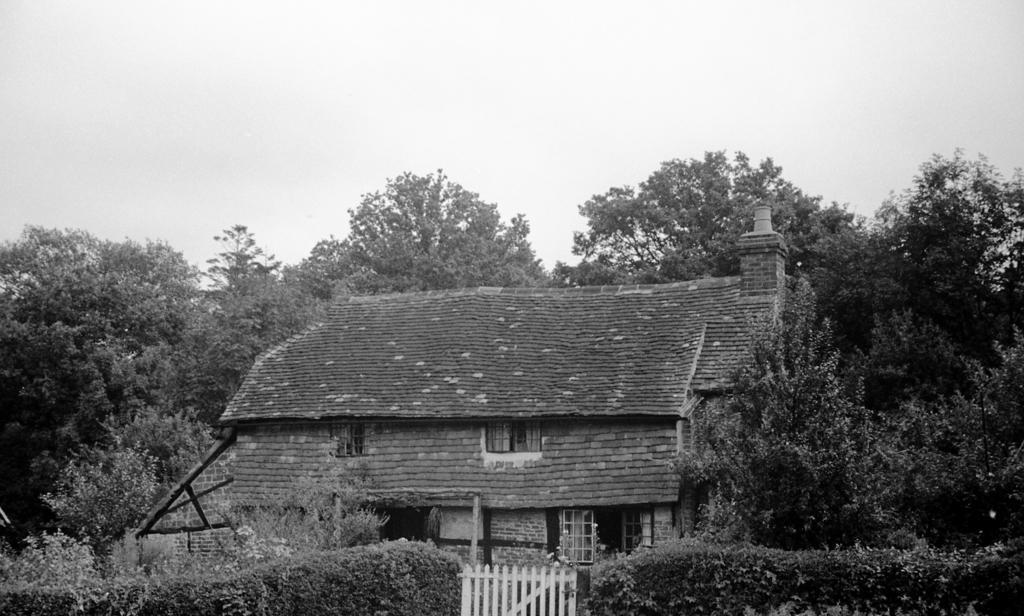How would you summarize this image in a sentence or two? This picture is clicked outside. In the foreground we can see that plants, trees, a white color gate and we can see the house and we can see the windows of the house. In the background we can see the sky, trees and some other objects. 